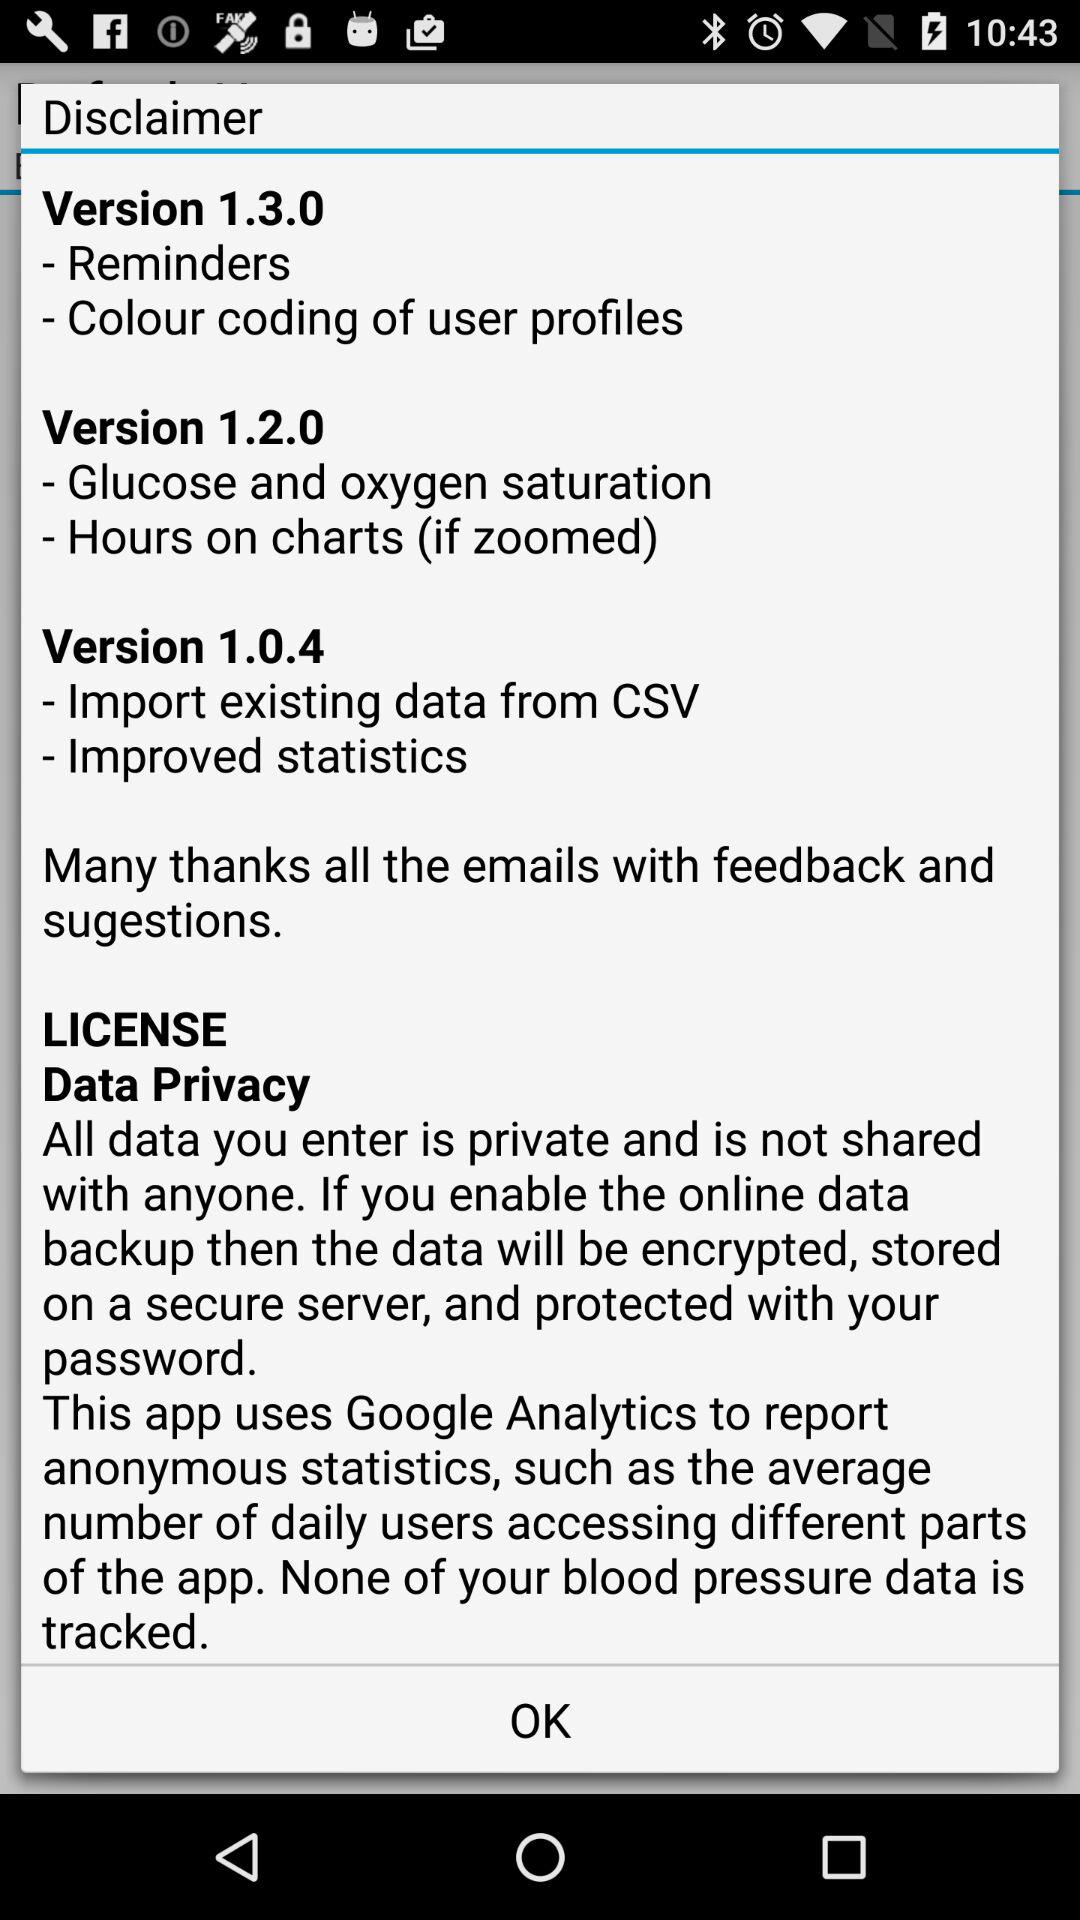Which version is the feature "Glucose and oxygen saturation" related to? The feature "Glucose and oxygen saturation" is related to version 1.2.0. 